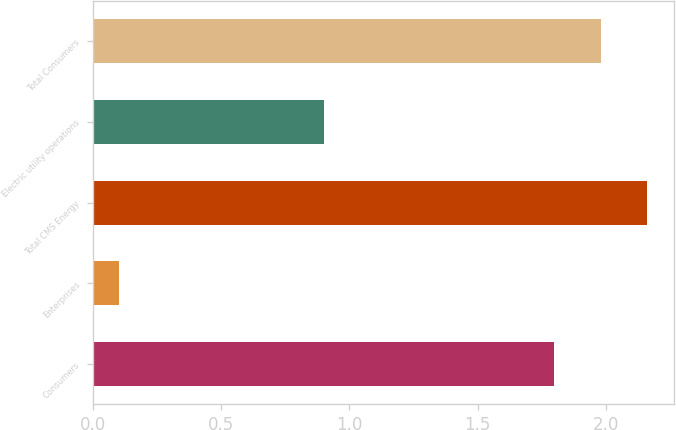<chart> <loc_0><loc_0><loc_500><loc_500><bar_chart><fcel>Consumers<fcel>Enterprises<fcel>Total CMS Energy<fcel>Electric utility operations<fcel>Total Consumers<nl><fcel>1.8<fcel>0.1<fcel>2.16<fcel>0.9<fcel>1.98<nl></chart> 